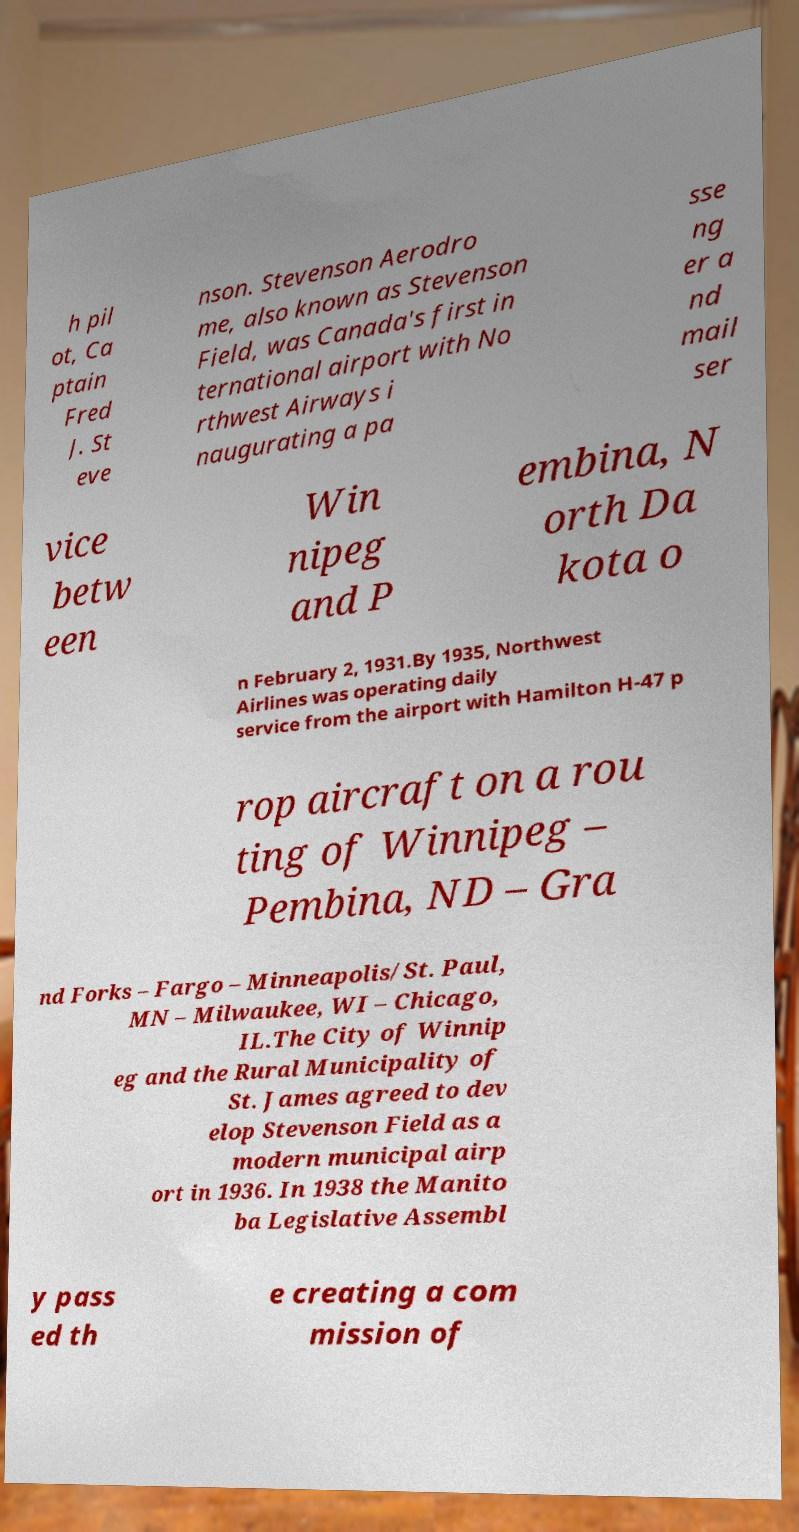For documentation purposes, I need the text within this image transcribed. Could you provide that? h pil ot, Ca ptain Fred J. St eve nson. Stevenson Aerodro me, also known as Stevenson Field, was Canada's first in ternational airport with No rthwest Airways i naugurating a pa sse ng er a nd mail ser vice betw een Win nipeg and P embina, N orth Da kota o n February 2, 1931.By 1935, Northwest Airlines was operating daily service from the airport with Hamilton H-47 p rop aircraft on a rou ting of Winnipeg – Pembina, ND – Gra nd Forks – Fargo – Minneapolis/St. Paul, MN – Milwaukee, WI – Chicago, IL.The City of Winnip eg and the Rural Municipality of St. James agreed to dev elop Stevenson Field as a modern municipal airp ort in 1936. In 1938 the Manito ba Legislative Assembl y pass ed th e creating a com mission of 